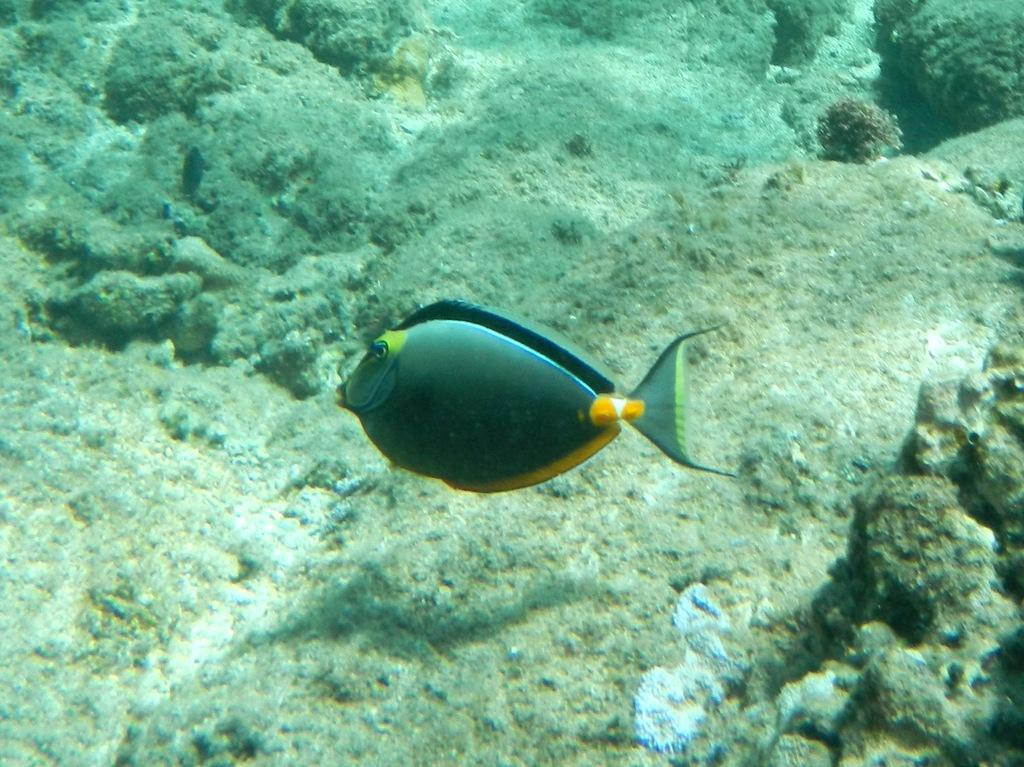Where was the image taken? The image is taken underwater. What can be seen in the center of the image? There is a fish in the center of the image. What is visible in the background of the image? There are rocks in the background of the image. What type of flag can be seen waving underwater in the image? There is no flag present in the image; it is taken underwater and features a fish and rocks in the background. 